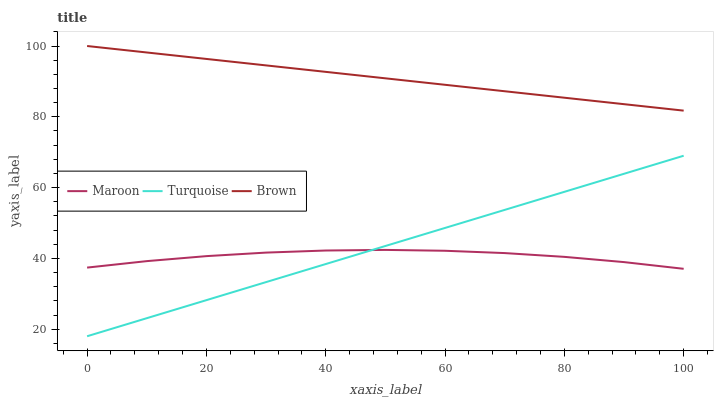Does Maroon have the minimum area under the curve?
Answer yes or no. Yes. Does Brown have the maximum area under the curve?
Answer yes or no. Yes. Does Turquoise have the minimum area under the curve?
Answer yes or no. No. Does Turquoise have the maximum area under the curve?
Answer yes or no. No. Is Turquoise the smoothest?
Answer yes or no. Yes. Is Maroon the roughest?
Answer yes or no. Yes. Is Maroon the smoothest?
Answer yes or no. No. Is Turquoise the roughest?
Answer yes or no. No. Does Turquoise have the lowest value?
Answer yes or no. Yes. Does Maroon have the lowest value?
Answer yes or no. No. Does Brown have the highest value?
Answer yes or no. Yes. Does Turquoise have the highest value?
Answer yes or no. No. Is Maroon less than Brown?
Answer yes or no. Yes. Is Brown greater than Turquoise?
Answer yes or no. Yes. Does Turquoise intersect Maroon?
Answer yes or no. Yes. Is Turquoise less than Maroon?
Answer yes or no. No. Is Turquoise greater than Maroon?
Answer yes or no. No. Does Maroon intersect Brown?
Answer yes or no. No. 